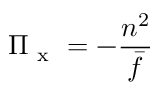<formula> <loc_0><loc_0><loc_500><loc_500>\Pi _ { x } = - \frac { n ^ { 2 } } { \bar { f } }</formula> 